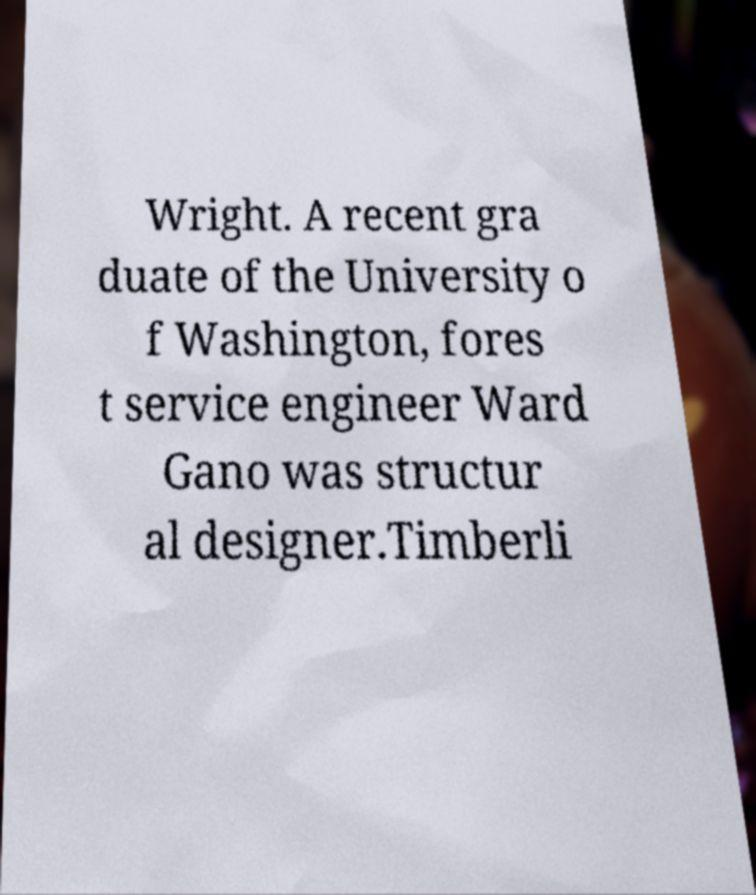Could you assist in decoding the text presented in this image and type it out clearly? Wright. A recent gra duate of the University o f Washington, fores t service engineer Ward Gano was structur al designer.Timberli 